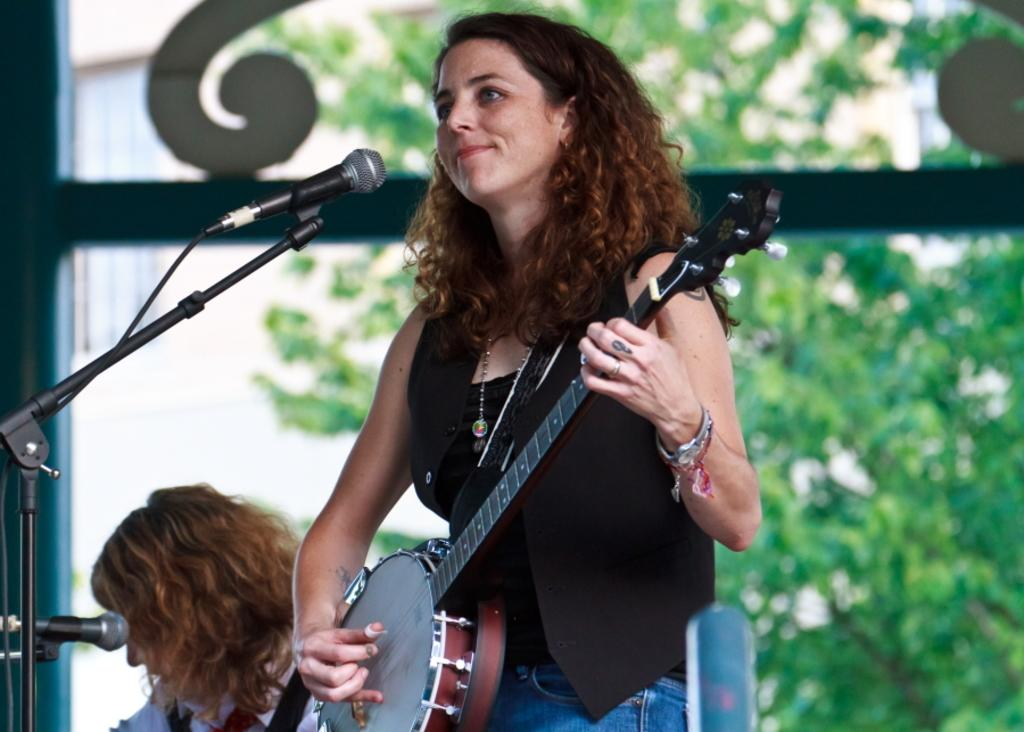What is the woman in the image doing? The woman is playing a guitar in the image. What objects are present that might be used for amplifying sound? There are microphones in the image. What can be seen in the background of the image? Trees are visible in the background of the image. What type of vegetable is being used as a stand for the guitar in the image? There is no vegetable present in the image, and the guitar is not being supported by any stand. What is the tin doing in the image? There is no tin present in the image. 